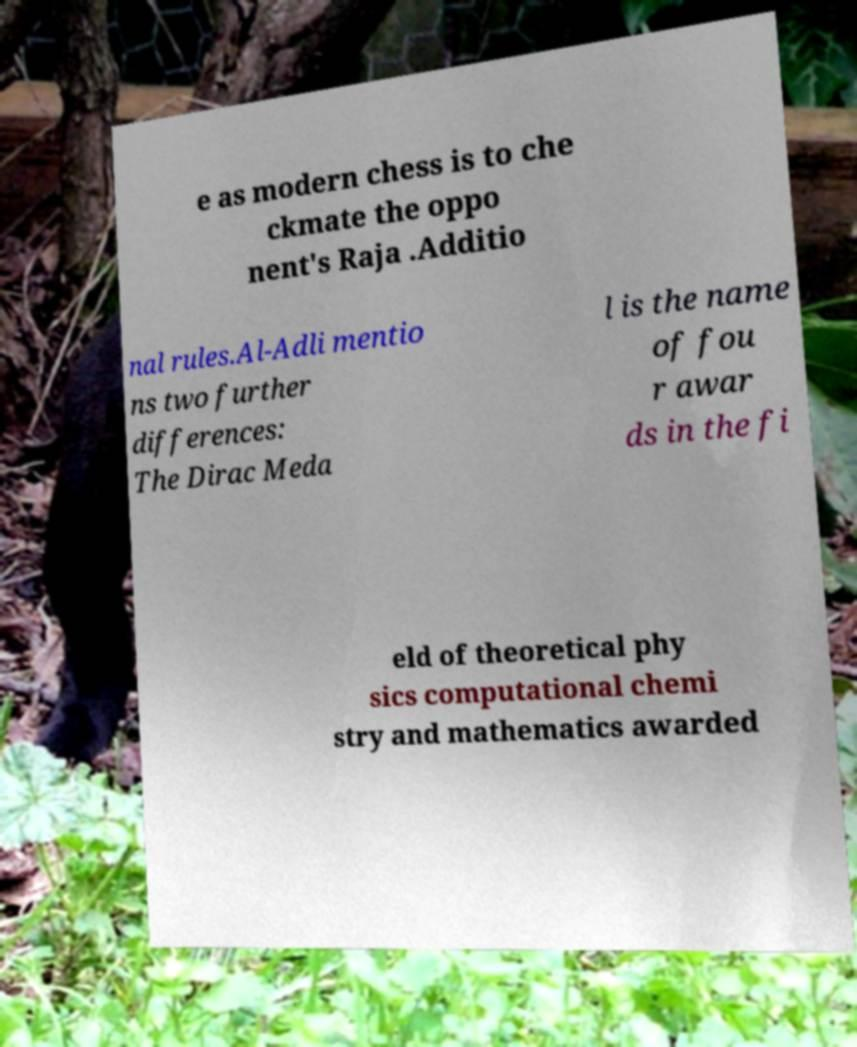Could you assist in decoding the text presented in this image and type it out clearly? e as modern chess is to che ckmate the oppo nent's Raja .Additio nal rules.Al-Adli mentio ns two further differences: The Dirac Meda l is the name of fou r awar ds in the fi eld of theoretical phy sics computational chemi stry and mathematics awarded 